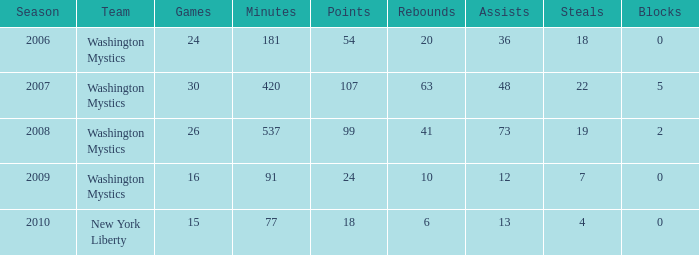What is the earliest year that Assists were less than 13 and minutes were under 91? None. 